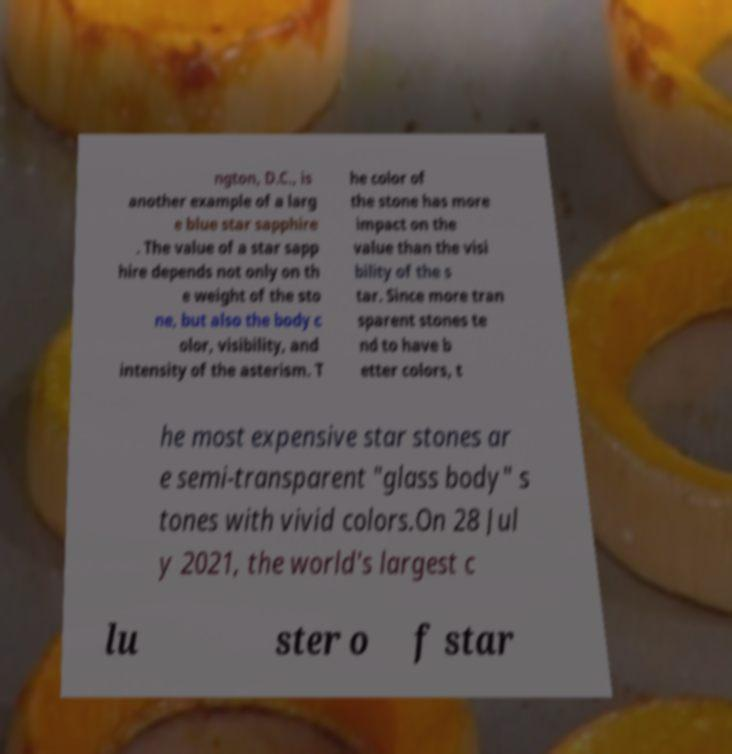Please read and relay the text visible in this image. What does it say? ngton, D.C., is another example of a larg e blue star sapphire . The value of a star sapp hire depends not only on th e weight of the sto ne, but also the body c olor, visibility, and intensity of the asterism. T he color of the stone has more impact on the value than the visi bility of the s tar. Since more tran sparent stones te nd to have b etter colors, t he most expensive star stones ar e semi-transparent "glass body" s tones with vivid colors.On 28 Jul y 2021, the world's largest c lu ster o f star 